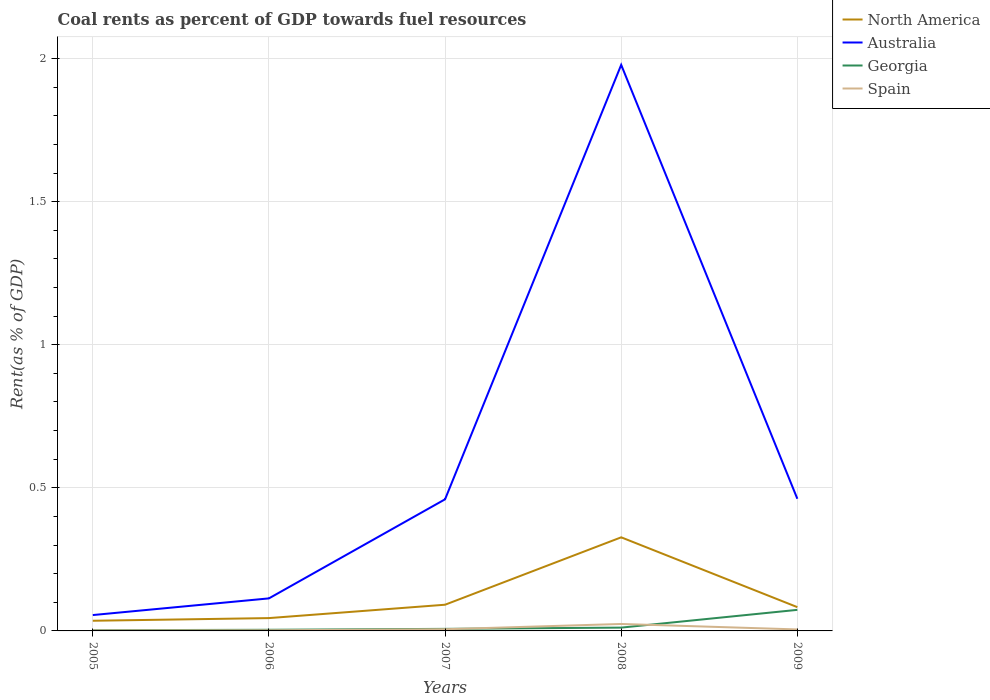Is the number of lines equal to the number of legend labels?
Keep it short and to the point. Yes. Across all years, what is the maximum coal rent in North America?
Offer a terse response. 0.04. In which year was the coal rent in Australia maximum?
Give a very brief answer. 2005. What is the total coal rent in Spain in the graph?
Your answer should be very brief. -0. What is the difference between the highest and the second highest coal rent in Australia?
Ensure brevity in your answer.  1.92. What is the difference between the highest and the lowest coal rent in North America?
Your answer should be very brief. 1. What is the difference between two consecutive major ticks on the Y-axis?
Offer a terse response. 0.5. Does the graph contain any zero values?
Provide a succinct answer. No. Does the graph contain grids?
Your answer should be compact. Yes. Where does the legend appear in the graph?
Offer a very short reply. Top right. What is the title of the graph?
Offer a very short reply. Coal rents as percent of GDP towards fuel resources. What is the label or title of the Y-axis?
Make the answer very short. Rent(as % of GDP). What is the Rent(as % of GDP) of North America in 2005?
Your response must be concise. 0.04. What is the Rent(as % of GDP) of Australia in 2005?
Provide a succinct answer. 0.06. What is the Rent(as % of GDP) in Georgia in 2005?
Provide a succinct answer. 0. What is the Rent(as % of GDP) of Spain in 2005?
Make the answer very short. 0. What is the Rent(as % of GDP) in North America in 2006?
Ensure brevity in your answer.  0.04. What is the Rent(as % of GDP) of Australia in 2006?
Offer a terse response. 0.11. What is the Rent(as % of GDP) in Georgia in 2006?
Keep it short and to the point. 0. What is the Rent(as % of GDP) of Spain in 2006?
Offer a very short reply. 0. What is the Rent(as % of GDP) in North America in 2007?
Make the answer very short. 0.09. What is the Rent(as % of GDP) in Australia in 2007?
Provide a succinct answer. 0.46. What is the Rent(as % of GDP) in Georgia in 2007?
Give a very brief answer. 0.01. What is the Rent(as % of GDP) in Spain in 2007?
Make the answer very short. 0.01. What is the Rent(as % of GDP) in North America in 2008?
Ensure brevity in your answer.  0.33. What is the Rent(as % of GDP) in Australia in 2008?
Offer a terse response. 1.98. What is the Rent(as % of GDP) in Georgia in 2008?
Make the answer very short. 0.01. What is the Rent(as % of GDP) in Spain in 2008?
Offer a very short reply. 0.02. What is the Rent(as % of GDP) of North America in 2009?
Give a very brief answer. 0.08. What is the Rent(as % of GDP) in Australia in 2009?
Offer a terse response. 0.46. What is the Rent(as % of GDP) of Georgia in 2009?
Provide a short and direct response. 0.07. What is the Rent(as % of GDP) in Spain in 2009?
Provide a succinct answer. 0.01. Across all years, what is the maximum Rent(as % of GDP) of North America?
Your answer should be compact. 0.33. Across all years, what is the maximum Rent(as % of GDP) of Australia?
Offer a very short reply. 1.98. Across all years, what is the maximum Rent(as % of GDP) in Georgia?
Provide a succinct answer. 0.07. Across all years, what is the maximum Rent(as % of GDP) in Spain?
Provide a succinct answer. 0.02. Across all years, what is the minimum Rent(as % of GDP) in North America?
Make the answer very short. 0.04. Across all years, what is the minimum Rent(as % of GDP) of Australia?
Offer a terse response. 0.06. Across all years, what is the minimum Rent(as % of GDP) in Georgia?
Offer a very short reply. 0. Across all years, what is the minimum Rent(as % of GDP) in Spain?
Provide a short and direct response. 0. What is the total Rent(as % of GDP) of North America in the graph?
Keep it short and to the point. 0.58. What is the total Rent(as % of GDP) in Australia in the graph?
Provide a short and direct response. 3.07. What is the total Rent(as % of GDP) of Georgia in the graph?
Give a very brief answer. 0.1. What is the total Rent(as % of GDP) of Spain in the graph?
Ensure brevity in your answer.  0.04. What is the difference between the Rent(as % of GDP) in North America in 2005 and that in 2006?
Keep it short and to the point. -0.01. What is the difference between the Rent(as % of GDP) of Australia in 2005 and that in 2006?
Give a very brief answer. -0.06. What is the difference between the Rent(as % of GDP) in Georgia in 2005 and that in 2006?
Give a very brief answer. -0. What is the difference between the Rent(as % of GDP) of Spain in 2005 and that in 2006?
Your answer should be compact. -0. What is the difference between the Rent(as % of GDP) in North America in 2005 and that in 2007?
Provide a short and direct response. -0.06. What is the difference between the Rent(as % of GDP) in Australia in 2005 and that in 2007?
Make the answer very short. -0.4. What is the difference between the Rent(as % of GDP) of Georgia in 2005 and that in 2007?
Provide a succinct answer. -0. What is the difference between the Rent(as % of GDP) of Spain in 2005 and that in 2007?
Give a very brief answer. -0. What is the difference between the Rent(as % of GDP) of North America in 2005 and that in 2008?
Give a very brief answer. -0.29. What is the difference between the Rent(as % of GDP) of Australia in 2005 and that in 2008?
Your answer should be very brief. -1.92. What is the difference between the Rent(as % of GDP) in Georgia in 2005 and that in 2008?
Offer a terse response. -0.01. What is the difference between the Rent(as % of GDP) of Spain in 2005 and that in 2008?
Your answer should be very brief. -0.02. What is the difference between the Rent(as % of GDP) of North America in 2005 and that in 2009?
Offer a very short reply. -0.05. What is the difference between the Rent(as % of GDP) of Australia in 2005 and that in 2009?
Provide a short and direct response. -0.41. What is the difference between the Rent(as % of GDP) in Georgia in 2005 and that in 2009?
Your answer should be compact. -0.07. What is the difference between the Rent(as % of GDP) of Spain in 2005 and that in 2009?
Provide a succinct answer. -0. What is the difference between the Rent(as % of GDP) of North America in 2006 and that in 2007?
Your answer should be very brief. -0.05. What is the difference between the Rent(as % of GDP) in Australia in 2006 and that in 2007?
Offer a terse response. -0.35. What is the difference between the Rent(as % of GDP) in Georgia in 2006 and that in 2007?
Your answer should be compact. -0. What is the difference between the Rent(as % of GDP) of Spain in 2006 and that in 2007?
Make the answer very short. -0. What is the difference between the Rent(as % of GDP) of North America in 2006 and that in 2008?
Offer a terse response. -0.28. What is the difference between the Rent(as % of GDP) in Australia in 2006 and that in 2008?
Your response must be concise. -1.86. What is the difference between the Rent(as % of GDP) in Georgia in 2006 and that in 2008?
Offer a very short reply. -0.01. What is the difference between the Rent(as % of GDP) in Spain in 2006 and that in 2008?
Your response must be concise. -0.02. What is the difference between the Rent(as % of GDP) of North America in 2006 and that in 2009?
Give a very brief answer. -0.04. What is the difference between the Rent(as % of GDP) of Australia in 2006 and that in 2009?
Offer a very short reply. -0.35. What is the difference between the Rent(as % of GDP) in Georgia in 2006 and that in 2009?
Keep it short and to the point. -0.07. What is the difference between the Rent(as % of GDP) of Spain in 2006 and that in 2009?
Your answer should be very brief. -0. What is the difference between the Rent(as % of GDP) of North America in 2007 and that in 2008?
Your answer should be very brief. -0.24. What is the difference between the Rent(as % of GDP) of Australia in 2007 and that in 2008?
Offer a terse response. -1.52. What is the difference between the Rent(as % of GDP) in Georgia in 2007 and that in 2008?
Provide a short and direct response. -0. What is the difference between the Rent(as % of GDP) of Spain in 2007 and that in 2008?
Provide a succinct answer. -0.02. What is the difference between the Rent(as % of GDP) in North America in 2007 and that in 2009?
Provide a succinct answer. 0.01. What is the difference between the Rent(as % of GDP) in Australia in 2007 and that in 2009?
Your answer should be very brief. -0. What is the difference between the Rent(as % of GDP) in Georgia in 2007 and that in 2009?
Ensure brevity in your answer.  -0.07. What is the difference between the Rent(as % of GDP) in Spain in 2007 and that in 2009?
Give a very brief answer. 0. What is the difference between the Rent(as % of GDP) of North America in 2008 and that in 2009?
Keep it short and to the point. 0.24. What is the difference between the Rent(as % of GDP) of Australia in 2008 and that in 2009?
Provide a short and direct response. 1.52. What is the difference between the Rent(as % of GDP) of Georgia in 2008 and that in 2009?
Give a very brief answer. -0.06. What is the difference between the Rent(as % of GDP) of Spain in 2008 and that in 2009?
Provide a succinct answer. 0.02. What is the difference between the Rent(as % of GDP) in North America in 2005 and the Rent(as % of GDP) in Australia in 2006?
Keep it short and to the point. -0.08. What is the difference between the Rent(as % of GDP) of North America in 2005 and the Rent(as % of GDP) of Georgia in 2006?
Offer a very short reply. 0.03. What is the difference between the Rent(as % of GDP) in North America in 2005 and the Rent(as % of GDP) in Spain in 2006?
Your answer should be very brief. 0.03. What is the difference between the Rent(as % of GDP) of Australia in 2005 and the Rent(as % of GDP) of Georgia in 2006?
Your response must be concise. 0.05. What is the difference between the Rent(as % of GDP) in Australia in 2005 and the Rent(as % of GDP) in Spain in 2006?
Your response must be concise. 0.05. What is the difference between the Rent(as % of GDP) in Georgia in 2005 and the Rent(as % of GDP) in Spain in 2006?
Keep it short and to the point. 0. What is the difference between the Rent(as % of GDP) in North America in 2005 and the Rent(as % of GDP) in Australia in 2007?
Your response must be concise. -0.42. What is the difference between the Rent(as % of GDP) of North America in 2005 and the Rent(as % of GDP) of Georgia in 2007?
Give a very brief answer. 0.03. What is the difference between the Rent(as % of GDP) of North America in 2005 and the Rent(as % of GDP) of Spain in 2007?
Provide a succinct answer. 0.03. What is the difference between the Rent(as % of GDP) of Australia in 2005 and the Rent(as % of GDP) of Georgia in 2007?
Give a very brief answer. 0.05. What is the difference between the Rent(as % of GDP) in Australia in 2005 and the Rent(as % of GDP) in Spain in 2007?
Offer a very short reply. 0.05. What is the difference between the Rent(as % of GDP) in Georgia in 2005 and the Rent(as % of GDP) in Spain in 2007?
Keep it short and to the point. -0. What is the difference between the Rent(as % of GDP) of North America in 2005 and the Rent(as % of GDP) of Australia in 2008?
Provide a succinct answer. -1.94. What is the difference between the Rent(as % of GDP) in North America in 2005 and the Rent(as % of GDP) in Georgia in 2008?
Offer a terse response. 0.02. What is the difference between the Rent(as % of GDP) in North America in 2005 and the Rent(as % of GDP) in Spain in 2008?
Offer a very short reply. 0.01. What is the difference between the Rent(as % of GDP) in Australia in 2005 and the Rent(as % of GDP) in Georgia in 2008?
Your answer should be very brief. 0.04. What is the difference between the Rent(as % of GDP) in Australia in 2005 and the Rent(as % of GDP) in Spain in 2008?
Your answer should be very brief. 0.03. What is the difference between the Rent(as % of GDP) of Georgia in 2005 and the Rent(as % of GDP) of Spain in 2008?
Your response must be concise. -0.02. What is the difference between the Rent(as % of GDP) in North America in 2005 and the Rent(as % of GDP) in Australia in 2009?
Your response must be concise. -0.43. What is the difference between the Rent(as % of GDP) of North America in 2005 and the Rent(as % of GDP) of Georgia in 2009?
Make the answer very short. -0.04. What is the difference between the Rent(as % of GDP) of North America in 2005 and the Rent(as % of GDP) of Spain in 2009?
Your response must be concise. 0.03. What is the difference between the Rent(as % of GDP) in Australia in 2005 and the Rent(as % of GDP) in Georgia in 2009?
Give a very brief answer. -0.02. What is the difference between the Rent(as % of GDP) of Australia in 2005 and the Rent(as % of GDP) of Spain in 2009?
Your answer should be very brief. 0.05. What is the difference between the Rent(as % of GDP) of Georgia in 2005 and the Rent(as % of GDP) of Spain in 2009?
Keep it short and to the point. -0. What is the difference between the Rent(as % of GDP) of North America in 2006 and the Rent(as % of GDP) of Australia in 2007?
Make the answer very short. -0.42. What is the difference between the Rent(as % of GDP) of North America in 2006 and the Rent(as % of GDP) of Georgia in 2007?
Keep it short and to the point. 0.04. What is the difference between the Rent(as % of GDP) in North America in 2006 and the Rent(as % of GDP) in Spain in 2007?
Provide a short and direct response. 0.04. What is the difference between the Rent(as % of GDP) in Australia in 2006 and the Rent(as % of GDP) in Georgia in 2007?
Give a very brief answer. 0.11. What is the difference between the Rent(as % of GDP) in Australia in 2006 and the Rent(as % of GDP) in Spain in 2007?
Make the answer very short. 0.11. What is the difference between the Rent(as % of GDP) in Georgia in 2006 and the Rent(as % of GDP) in Spain in 2007?
Give a very brief answer. -0. What is the difference between the Rent(as % of GDP) of North America in 2006 and the Rent(as % of GDP) of Australia in 2008?
Your response must be concise. -1.93. What is the difference between the Rent(as % of GDP) of North America in 2006 and the Rent(as % of GDP) of Georgia in 2008?
Provide a short and direct response. 0.03. What is the difference between the Rent(as % of GDP) of North America in 2006 and the Rent(as % of GDP) of Spain in 2008?
Keep it short and to the point. 0.02. What is the difference between the Rent(as % of GDP) of Australia in 2006 and the Rent(as % of GDP) of Georgia in 2008?
Offer a terse response. 0.1. What is the difference between the Rent(as % of GDP) of Australia in 2006 and the Rent(as % of GDP) of Spain in 2008?
Offer a terse response. 0.09. What is the difference between the Rent(as % of GDP) in Georgia in 2006 and the Rent(as % of GDP) in Spain in 2008?
Ensure brevity in your answer.  -0.02. What is the difference between the Rent(as % of GDP) in North America in 2006 and the Rent(as % of GDP) in Australia in 2009?
Your answer should be very brief. -0.42. What is the difference between the Rent(as % of GDP) in North America in 2006 and the Rent(as % of GDP) in Georgia in 2009?
Offer a very short reply. -0.03. What is the difference between the Rent(as % of GDP) of North America in 2006 and the Rent(as % of GDP) of Spain in 2009?
Your response must be concise. 0.04. What is the difference between the Rent(as % of GDP) in Australia in 2006 and the Rent(as % of GDP) in Georgia in 2009?
Your answer should be compact. 0.04. What is the difference between the Rent(as % of GDP) of Australia in 2006 and the Rent(as % of GDP) of Spain in 2009?
Your answer should be very brief. 0.11. What is the difference between the Rent(as % of GDP) in Georgia in 2006 and the Rent(as % of GDP) in Spain in 2009?
Ensure brevity in your answer.  -0. What is the difference between the Rent(as % of GDP) of North America in 2007 and the Rent(as % of GDP) of Australia in 2008?
Make the answer very short. -1.89. What is the difference between the Rent(as % of GDP) in North America in 2007 and the Rent(as % of GDP) in Georgia in 2008?
Give a very brief answer. 0.08. What is the difference between the Rent(as % of GDP) of North America in 2007 and the Rent(as % of GDP) of Spain in 2008?
Your response must be concise. 0.07. What is the difference between the Rent(as % of GDP) of Australia in 2007 and the Rent(as % of GDP) of Georgia in 2008?
Offer a terse response. 0.45. What is the difference between the Rent(as % of GDP) of Australia in 2007 and the Rent(as % of GDP) of Spain in 2008?
Offer a very short reply. 0.44. What is the difference between the Rent(as % of GDP) of Georgia in 2007 and the Rent(as % of GDP) of Spain in 2008?
Make the answer very short. -0.02. What is the difference between the Rent(as % of GDP) in North America in 2007 and the Rent(as % of GDP) in Australia in 2009?
Your answer should be very brief. -0.37. What is the difference between the Rent(as % of GDP) in North America in 2007 and the Rent(as % of GDP) in Georgia in 2009?
Provide a short and direct response. 0.02. What is the difference between the Rent(as % of GDP) of North America in 2007 and the Rent(as % of GDP) of Spain in 2009?
Your answer should be very brief. 0.09. What is the difference between the Rent(as % of GDP) in Australia in 2007 and the Rent(as % of GDP) in Georgia in 2009?
Your answer should be very brief. 0.39. What is the difference between the Rent(as % of GDP) in Australia in 2007 and the Rent(as % of GDP) in Spain in 2009?
Provide a succinct answer. 0.45. What is the difference between the Rent(as % of GDP) in Georgia in 2007 and the Rent(as % of GDP) in Spain in 2009?
Your answer should be very brief. 0. What is the difference between the Rent(as % of GDP) in North America in 2008 and the Rent(as % of GDP) in Australia in 2009?
Your answer should be compact. -0.13. What is the difference between the Rent(as % of GDP) of North America in 2008 and the Rent(as % of GDP) of Georgia in 2009?
Offer a terse response. 0.25. What is the difference between the Rent(as % of GDP) in North America in 2008 and the Rent(as % of GDP) in Spain in 2009?
Provide a succinct answer. 0.32. What is the difference between the Rent(as % of GDP) of Australia in 2008 and the Rent(as % of GDP) of Georgia in 2009?
Make the answer very short. 1.9. What is the difference between the Rent(as % of GDP) in Australia in 2008 and the Rent(as % of GDP) in Spain in 2009?
Offer a very short reply. 1.97. What is the difference between the Rent(as % of GDP) in Georgia in 2008 and the Rent(as % of GDP) in Spain in 2009?
Make the answer very short. 0.01. What is the average Rent(as % of GDP) in North America per year?
Your answer should be compact. 0.12. What is the average Rent(as % of GDP) of Australia per year?
Make the answer very short. 0.61. What is the average Rent(as % of GDP) in Georgia per year?
Ensure brevity in your answer.  0.02. What is the average Rent(as % of GDP) in Spain per year?
Offer a terse response. 0.01. In the year 2005, what is the difference between the Rent(as % of GDP) of North America and Rent(as % of GDP) of Australia?
Your response must be concise. -0.02. In the year 2005, what is the difference between the Rent(as % of GDP) of North America and Rent(as % of GDP) of Georgia?
Provide a short and direct response. 0.03. In the year 2005, what is the difference between the Rent(as % of GDP) of North America and Rent(as % of GDP) of Spain?
Your response must be concise. 0.03. In the year 2005, what is the difference between the Rent(as % of GDP) of Australia and Rent(as % of GDP) of Georgia?
Offer a terse response. 0.05. In the year 2005, what is the difference between the Rent(as % of GDP) in Australia and Rent(as % of GDP) in Spain?
Your answer should be compact. 0.05. In the year 2005, what is the difference between the Rent(as % of GDP) in Georgia and Rent(as % of GDP) in Spain?
Offer a terse response. 0. In the year 2006, what is the difference between the Rent(as % of GDP) of North America and Rent(as % of GDP) of Australia?
Your answer should be very brief. -0.07. In the year 2006, what is the difference between the Rent(as % of GDP) in North America and Rent(as % of GDP) in Georgia?
Your answer should be compact. 0.04. In the year 2006, what is the difference between the Rent(as % of GDP) in North America and Rent(as % of GDP) in Spain?
Your answer should be very brief. 0.04. In the year 2006, what is the difference between the Rent(as % of GDP) in Australia and Rent(as % of GDP) in Georgia?
Ensure brevity in your answer.  0.11. In the year 2006, what is the difference between the Rent(as % of GDP) in Australia and Rent(as % of GDP) in Spain?
Provide a succinct answer. 0.11. In the year 2006, what is the difference between the Rent(as % of GDP) of Georgia and Rent(as % of GDP) of Spain?
Make the answer very short. 0. In the year 2007, what is the difference between the Rent(as % of GDP) of North America and Rent(as % of GDP) of Australia?
Offer a terse response. -0.37. In the year 2007, what is the difference between the Rent(as % of GDP) in North America and Rent(as % of GDP) in Georgia?
Provide a short and direct response. 0.08. In the year 2007, what is the difference between the Rent(as % of GDP) in North America and Rent(as % of GDP) in Spain?
Keep it short and to the point. 0.09. In the year 2007, what is the difference between the Rent(as % of GDP) of Australia and Rent(as % of GDP) of Georgia?
Keep it short and to the point. 0.45. In the year 2007, what is the difference between the Rent(as % of GDP) of Australia and Rent(as % of GDP) of Spain?
Offer a terse response. 0.45. In the year 2007, what is the difference between the Rent(as % of GDP) in Georgia and Rent(as % of GDP) in Spain?
Give a very brief answer. 0. In the year 2008, what is the difference between the Rent(as % of GDP) of North America and Rent(as % of GDP) of Australia?
Your answer should be very brief. -1.65. In the year 2008, what is the difference between the Rent(as % of GDP) in North America and Rent(as % of GDP) in Georgia?
Provide a succinct answer. 0.32. In the year 2008, what is the difference between the Rent(as % of GDP) of North America and Rent(as % of GDP) of Spain?
Your answer should be very brief. 0.3. In the year 2008, what is the difference between the Rent(as % of GDP) of Australia and Rent(as % of GDP) of Georgia?
Give a very brief answer. 1.97. In the year 2008, what is the difference between the Rent(as % of GDP) of Australia and Rent(as % of GDP) of Spain?
Offer a very short reply. 1.95. In the year 2008, what is the difference between the Rent(as % of GDP) in Georgia and Rent(as % of GDP) in Spain?
Give a very brief answer. -0.01. In the year 2009, what is the difference between the Rent(as % of GDP) in North America and Rent(as % of GDP) in Australia?
Offer a very short reply. -0.38. In the year 2009, what is the difference between the Rent(as % of GDP) of North America and Rent(as % of GDP) of Georgia?
Your answer should be compact. 0.01. In the year 2009, what is the difference between the Rent(as % of GDP) of North America and Rent(as % of GDP) of Spain?
Your response must be concise. 0.08. In the year 2009, what is the difference between the Rent(as % of GDP) of Australia and Rent(as % of GDP) of Georgia?
Ensure brevity in your answer.  0.39. In the year 2009, what is the difference between the Rent(as % of GDP) in Australia and Rent(as % of GDP) in Spain?
Give a very brief answer. 0.46. In the year 2009, what is the difference between the Rent(as % of GDP) of Georgia and Rent(as % of GDP) of Spain?
Make the answer very short. 0.07. What is the ratio of the Rent(as % of GDP) in North America in 2005 to that in 2006?
Your response must be concise. 0.79. What is the ratio of the Rent(as % of GDP) of Australia in 2005 to that in 2006?
Make the answer very short. 0.49. What is the ratio of the Rent(as % of GDP) in Georgia in 2005 to that in 2006?
Your answer should be compact. 0.6. What is the ratio of the Rent(as % of GDP) in Spain in 2005 to that in 2006?
Your response must be concise. 0.76. What is the ratio of the Rent(as % of GDP) in North America in 2005 to that in 2007?
Offer a terse response. 0.39. What is the ratio of the Rent(as % of GDP) in Australia in 2005 to that in 2007?
Offer a terse response. 0.12. What is the ratio of the Rent(as % of GDP) of Georgia in 2005 to that in 2007?
Offer a terse response. 0.33. What is the ratio of the Rent(as % of GDP) of Spain in 2005 to that in 2007?
Your answer should be very brief. 0.28. What is the ratio of the Rent(as % of GDP) in North America in 2005 to that in 2008?
Offer a terse response. 0.11. What is the ratio of the Rent(as % of GDP) in Australia in 2005 to that in 2008?
Offer a very short reply. 0.03. What is the ratio of the Rent(as % of GDP) of Georgia in 2005 to that in 2008?
Make the answer very short. 0.21. What is the ratio of the Rent(as % of GDP) in Spain in 2005 to that in 2008?
Your answer should be very brief. 0.07. What is the ratio of the Rent(as % of GDP) in North America in 2005 to that in 2009?
Offer a terse response. 0.43. What is the ratio of the Rent(as % of GDP) of Australia in 2005 to that in 2009?
Give a very brief answer. 0.12. What is the ratio of the Rent(as % of GDP) of Georgia in 2005 to that in 2009?
Offer a terse response. 0.03. What is the ratio of the Rent(as % of GDP) in Spain in 2005 to that in 2009?
Give a very brief answer. 0.32. What is the ratio of the Rent(as % of GDP) of North America in 2006 to that in 2007?
Your response must be concise. 0.49. What is the ratio of the Rent(as % of GDP) of Australia in 2006 to that in 2007?
Your answer should be compact. 0.25. What is the ratio of the Rent(as % of GDP) in Georgia in 2006 to that in 2007?
Your answer should be compact. 0.56. What is the ratio of the Rent(as % of GDP) of Spain in 2006 to that in 2007?
Your answer should be compact. 0.37. What is the ratio of the Rent(as % of GDP) in North America in 2006 to that in 2008?
Keep it short and to the point. 0.14. What is the ratio of the Rent(as % of GDP) of Australia in 2006 to that in 2008?
Provide a short and direct response. 0.06. What is the ratio of the Rent(as % of GDP) in Georgia in 2006 to that in 2008?
Make the answer very short. 0.35. What is the ratio of the Rent(as % of GDP) in Spain in 2006 to that in 2008?
Offer a terse response. 0.09. What is the ratio of the Rent(as % of GDP) of North America in 2006 to that in 2009?
Provide a short and direct response. 0.54. What is the ratio of the Rent(as % of GDP) of Australia in 2006 to that in 2009?
Provide a short and direct response. 0.25. What is the ratio of the Rent(as % of GDP) in Georgia in 2006 to that in 2009?
Your response must be concise. 0.05. What is the ratio of the Rent(as % of GDP) in Spain in 2006 to that in 2009?
Provide a succinct answer. 0.42. What is the ratio of the Rent(as % of GDP) in North America in 2007 to that in 2008?
Keep it short and to the point. 0.28. What is the ratio of the Rent(as % of GDP) of Australia in 2007 to that in 2008?
Ensure brevity in your answer.  0.23. What is the ratio of the Rent(as % of GDP) in Georgia in 2007 to that in 2008?
Provide a short and direct response. 0.62. What is the ratio of the Rent(as % of GDP) of Spain in 2007 to that in 2008?
Provide a succinct answer. 0.24. What is the ratio of the Rent(as % of GDP) in North America in 2007 to that in 2009?
Your response must be concise. 1.1. What is the ratio of the Rent(as % of GDP) in Georgia in 2007 to that in 2009?
Give a very brief answer. 0.1. What is the ratio of the Rent(as % of GDP) of Spain in 2007 to that in 2009?
Provide a succinct answer. 1.14. What is the ratio of the Rent(as % of GDP) of North America in 2008 to that in 2009?
Your response must be concise. 3.93. What is the ratio of the Rent(as % of GDP) of Australia in 2008 to that in 2009?
Keep it short and to the point. 4.28. What is the ratio of the Rent(as % of GDP) in Georgia in 2008 to that in 2009?
Your answer should be very brief. 0.16. What is the ratio of the Rent(as % of GDP) of Spain in 2008 to that in 2009?
Keep it short and to the point. 4.67. What is the difference between the highest and the second highest Rent(as % of GDP) in North America?
Offer a terse response. 0.24. What is the difference between the highest and the second highest Rent(as % of GDP) of Australia?
Offer a very short reply. 1.52. What is the difference between the highest and the second highest Rent(as % of GDP) of Georgia?
Keep it short and to the point. 0.06. What is the difference between the highest and the second highest Rent(as % of GDP) in Spain?
Offer a terse response. 0.02. What is the difference between the highest and the lowest Rent(as % of GDP) in North America?
Your answer should be very brief. 0.29. What is the difference between the highest and the lowest Rent(as % of GDP) in Australia?
Ensure brevity in your answer.  1.92. What is the difference between the highest and the lowest Rent(as % of GDP) in Georgia?
Keep it short and to the point. 0.07. What is the difference between the highest and the lowest Rent(as % of GDP) in Spain?
Provide a short and direct response. 0.02. 